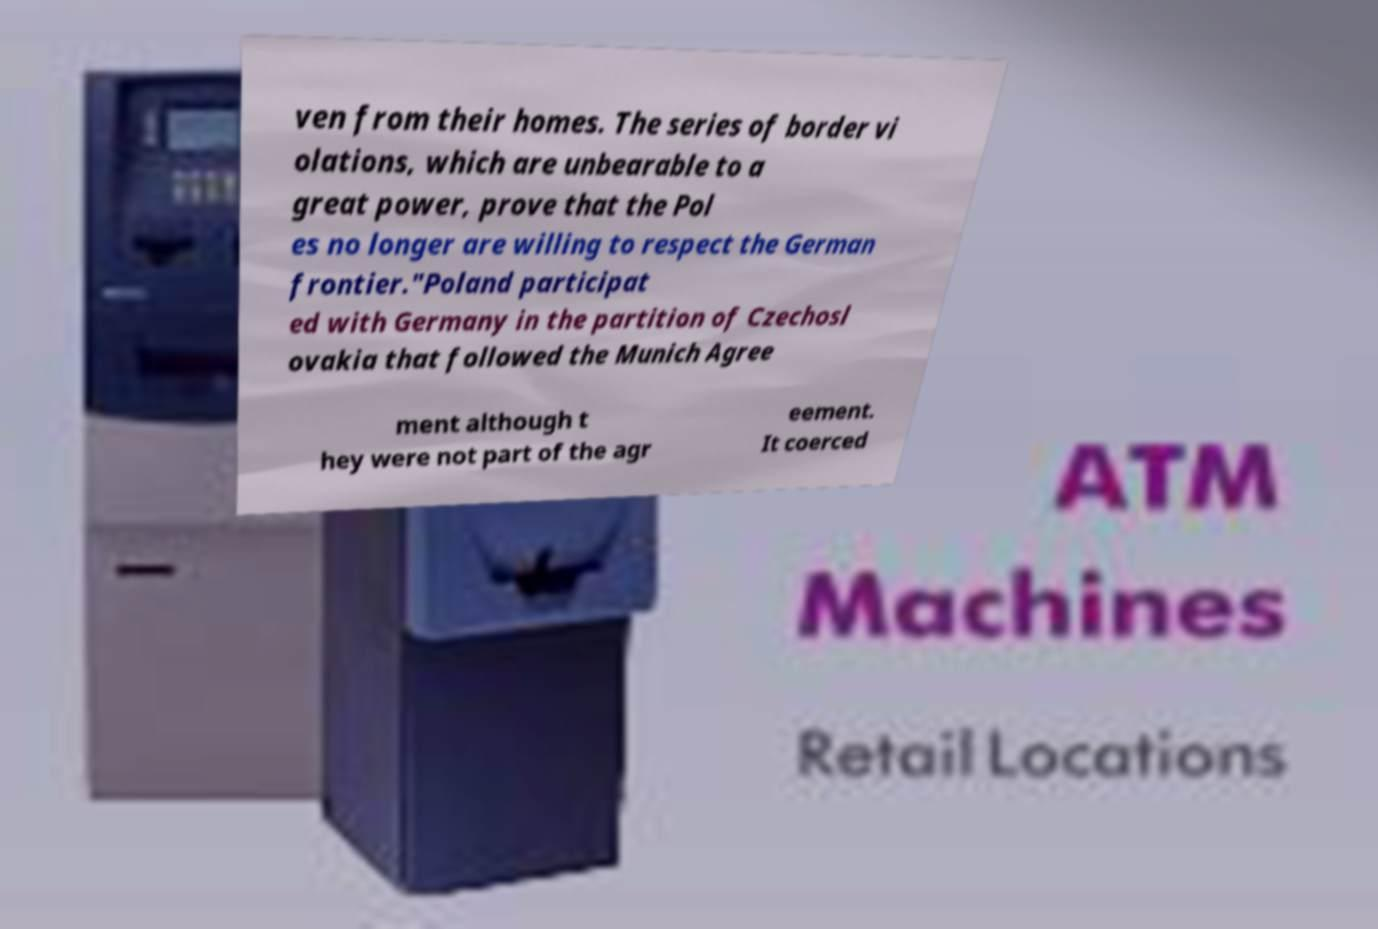Could you assist in decoding the text presented in this image and type it out clearly? ven from their homes. The series of border vi olations, which are unbearable to a great power, prove that the Pol es no longer are willing to respect the German frontier."Poland participat ed with Germany in the partition of Czechosl ovakia that followed the Munich Agree ment although t hey were not part of the agr eement. It coerced 